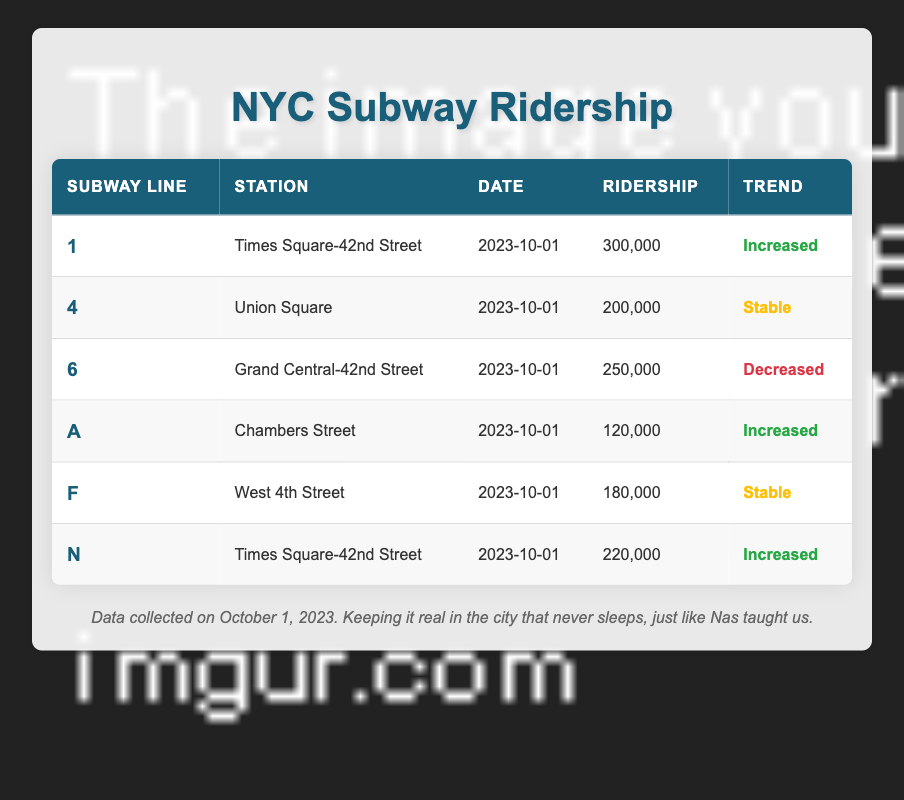What is the ridership for the 1 subway line at Times Square-42nd Street? From the table, the ridership listed for subway line 1 at the Times Square-42nd Street station is 300,000.
Answer: 300,000 Which subway line has the highest ridership on October 1, 2023? The table shows that subway line 1 at Times Square-42nd Street has the highest ridership with 300,000, compared to all other listed lines.
Answer: 1 Is the trend for the 6 subway line at Grand Central-42nd Street stable? According to the table, the trend for the 6 subway line is indicated as "decreased," thus it is not stable.
Answer: No How many subway lines showed an increase in ridership on October 1, 2023? From the table, the subway lines A, 1, and N are noted to have an increased trend in ridership. Counting these lines gives us 3 that showed an increase.
Answer: 3 What is the total ridership for the subway lines that have stable trends? Examining the table, the lines with stable trends are 4 and F, with riderships of 200,000 and 180,000 respectively. Summing these gives us 200,000 + 180,000 = 380,000.
Answer: 380,000 Which subway line at Times Square-42nd Street has the higher ridership on October 1, 2023? The table lists two subway lines at Times Square-42nd Street: line 1 (300,000 ridership) and line N (220,000 ridership). Comparing these, line 1 has the higher ridership.
Answer: 1 Was there any subway line that decreased ridership from previous statistics? The table shows that the 6 subway line has a trend marked as "decreased," indicating a drop in ridership.
Answer: Yes What is the average ridership for the subway lines with an increased trend? The lines with an increased trend are 1, A, and N, with riderships of 300,000, 120,000, and 220,000 respectively. The total is 300,000 + 120,000 + 220,000 = 640,000. Dividing this by the 3 lines gives an average of 640,000 / 3 ≈ 213,333.
Answer: 213,333 Which station has the lowest ridership on October 1, 2023? From the table, the line A at Chambers Street has the lowest ridership figure of 120,000 compared to other stations.
Answer: Chambers Street 